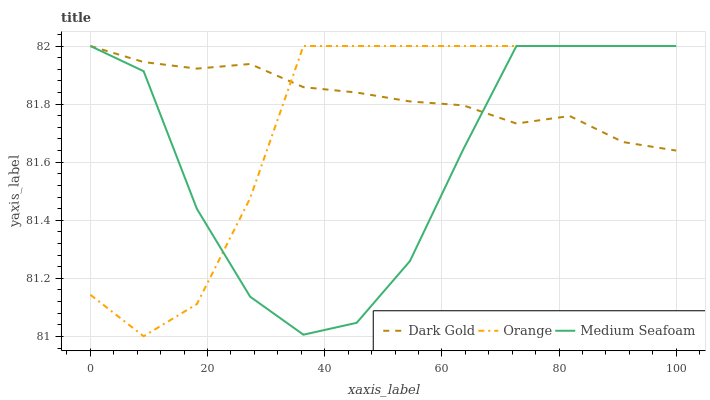Does Medium Seafoam have the minimum area under the curve?
Answer yes or no. Yes. Does Dark Gold have the maximum area under the curve?
Answer yes or no. Yes. Does Dark Gold have the minimum area under the curve?
Answer yes or no. No. Does Medium Seafoam have the maximum area under the curve?
Answer yes or no. No. Is Dark Gold the smoothest?
Answer yes or no. Yes. Is Medium Seafoam the roughest?
Answer yes or no. Yes. Is Medium Seafoam the smoothest?
Answer yes or no. No. Is Dark Gold the roughest?
Answer yes or no. No. Does Orange have the lowest value?
Answer yes or no. Yes. Does Medium Seafoam have the lowest value?
Answer yes or no. No. Does Dark Gold have the highest value?
Answer yes or no. Yes. Does Orange intersect Medium Seafoam?
Answer yes or no. Yes. Is Orange less than Medium Seafoam?
Answer yes or no. No. Is Orange greater than Medium Seafoam?
Answer yes or no. No. 